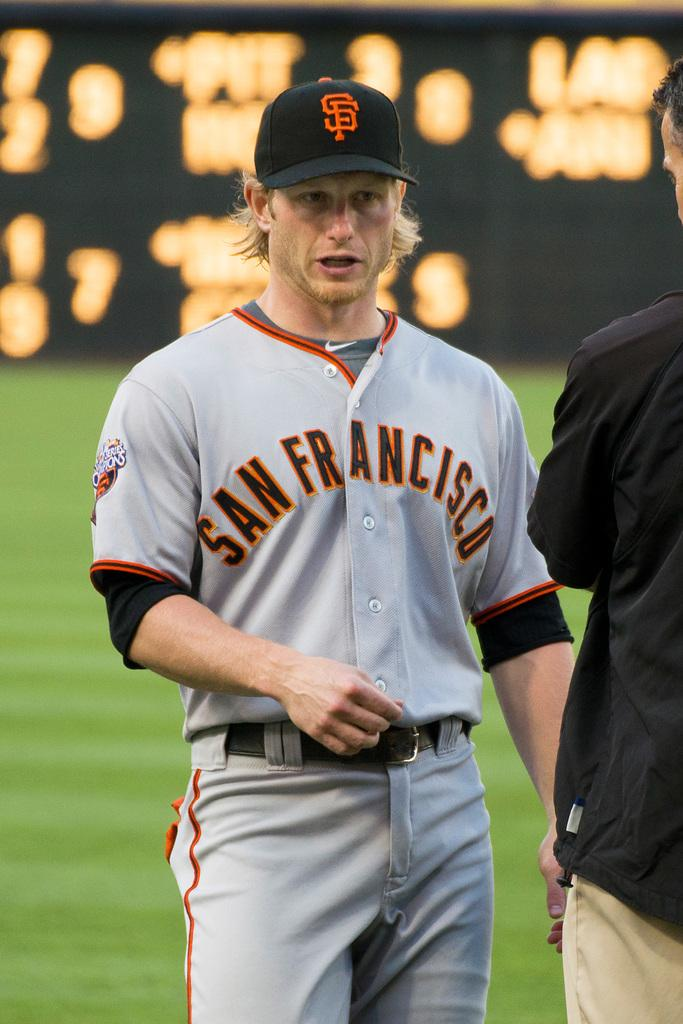<image>
Create a compact narrative representing the image presented. A baseball player standing in a stadium and wearing a San Francisco Giants uniform. 